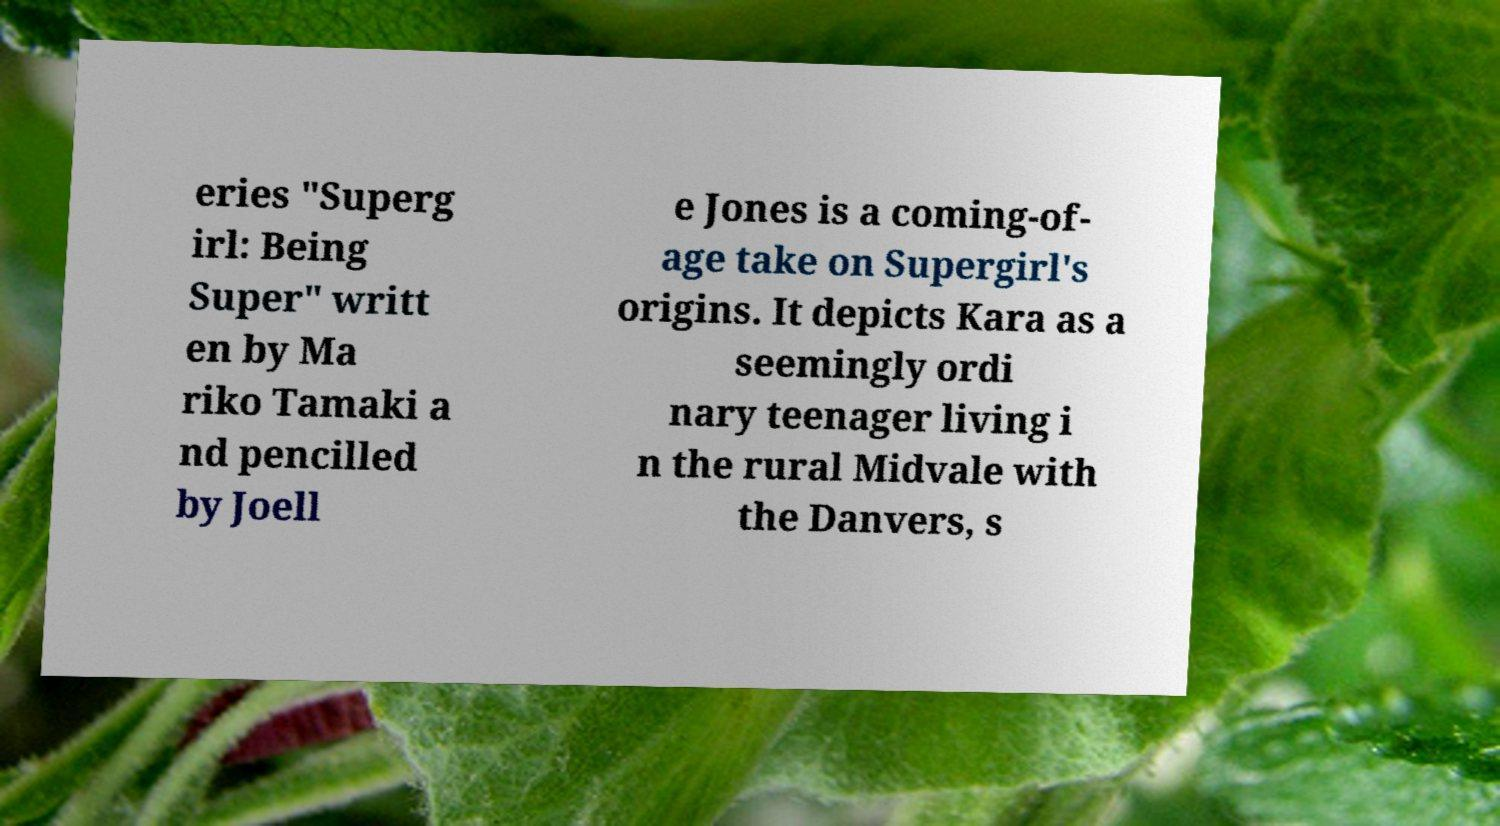Could you assist in decoding the text presented in this image and type it out clearly? eries "Superg irl: Being Super" writt en by Ma riko Tamaki a nd pencilled by Joell e Jones is a coming-of- age take on Supergirl's origins. It depicts Kara as a seemingly ordi nary teenager living i n the rural Midvale with the Danvers, s 